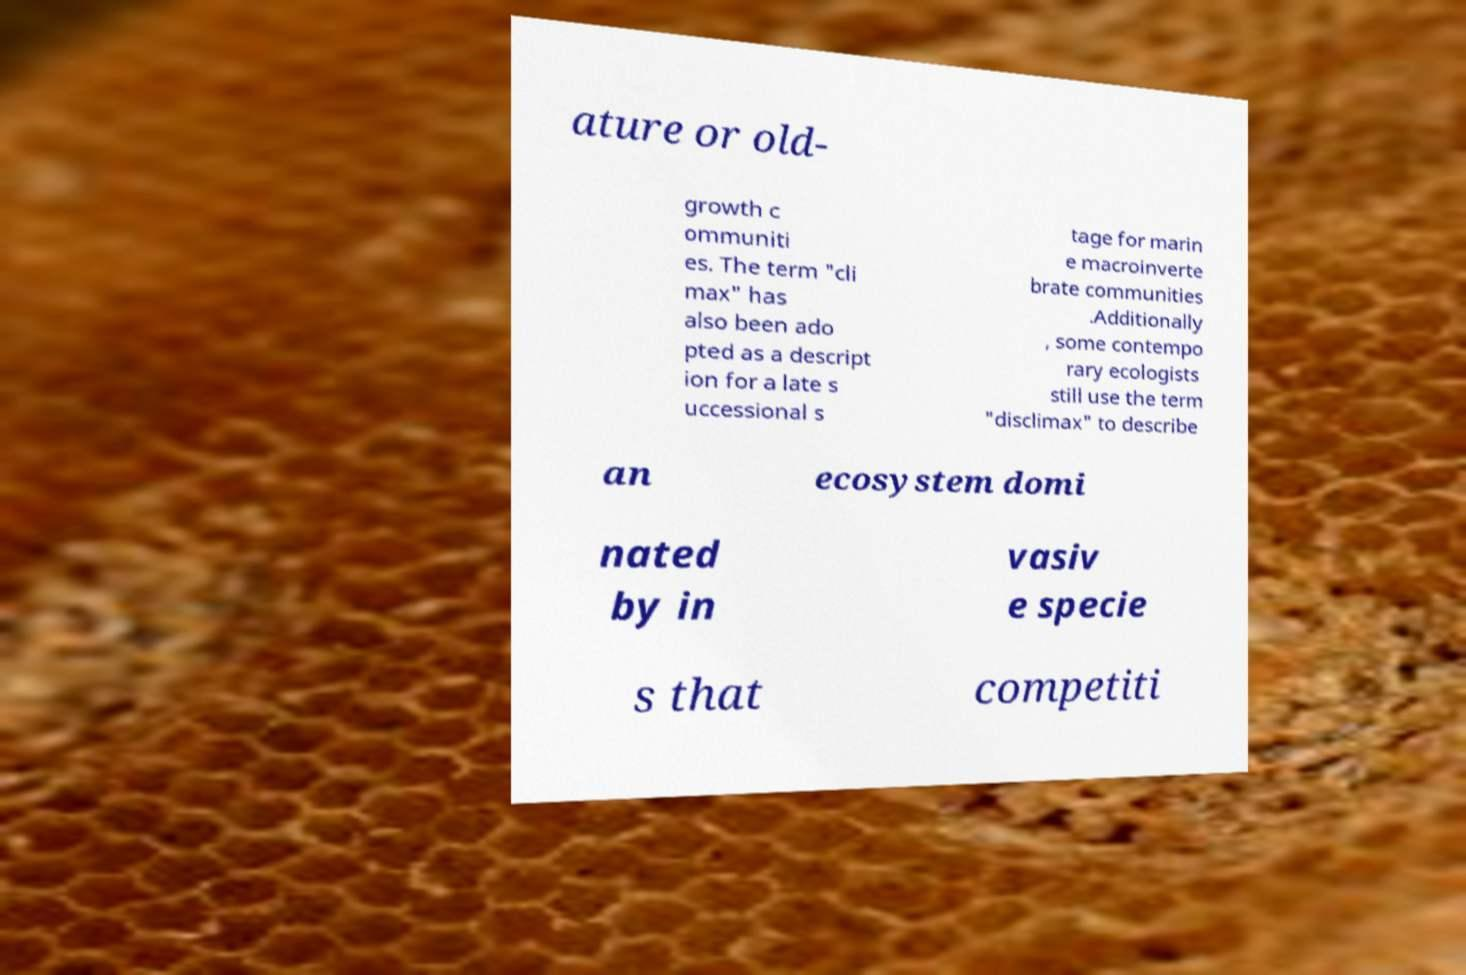Could you assist in decoding the text presented in this image and type it out clearly? ature or old- growth c ommuniti es. The term "cli max" has also been ado pted as a descript ion for a late s uccessional s tage for marin e macroinverte brate communities .Additionally , some contempo rary ecologists still use the term "disclimax" to describe an ecosystem domi nated by in vasiv e specie s that competiti 